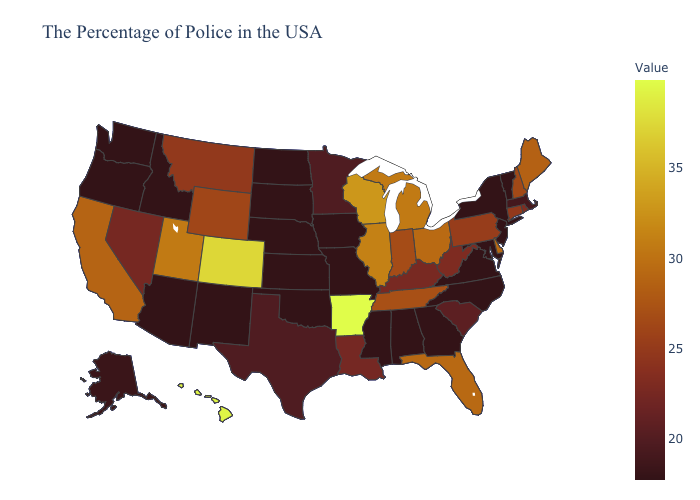Among the states that border Connecticut , which have the highest value?
Give a very brief answer. Rhode Island. Among the states that border Missouri , which have the lowest value?
Answer briefly. Iowa, Kansas, Nebraska, Oklahoma. Which states have the highest value in the USA?
Write a very short answer. Arkansas. Does North Dakota have the lowest value in the MidWest?
Short answer required. Yes. Does the map have missing data?
Give a very brief answer. No. 